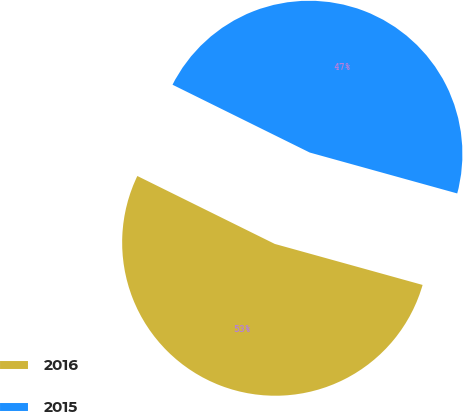Convert chart to OTSL. <chart><loc_0><loc_0><loc_500><loc_500><pie_chart><fcel>2016<fcel>2015<nl><fcel>53.0%<fcel>47.0%<nl></chart> 